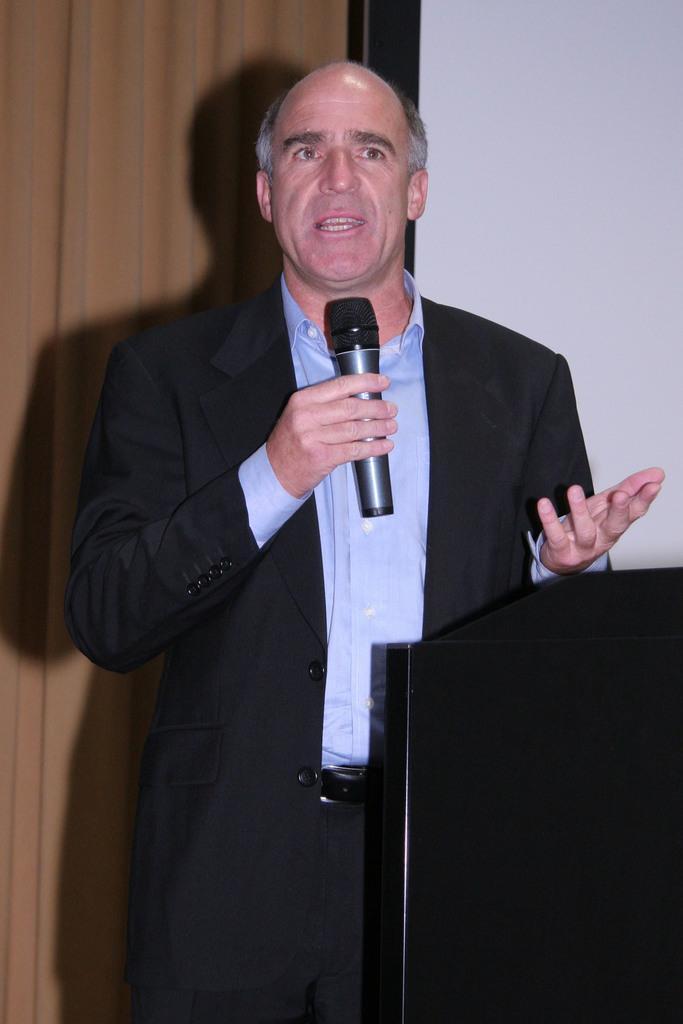Could you give a brief overview of what you see in this image? This picture is of inside. In the center there is a man wearing suit, holding a microphone, standing and talking. On the right there is a podium. In the background we can see a wall and a curtain. 